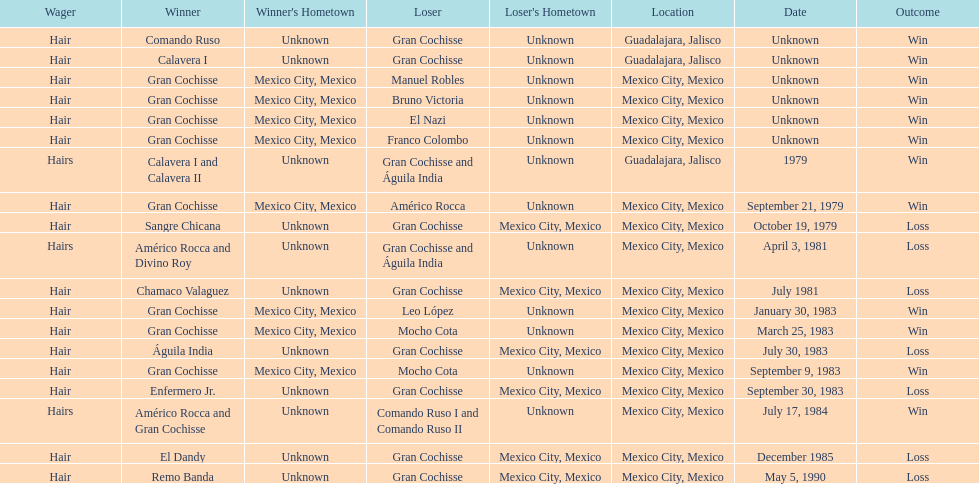How many times has the wager been hair? 16. 